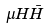Convert formula to latex. <formula><loc_0><loc_0><loc_500><loc_500>\mu H { \bar { H } }</formula> 